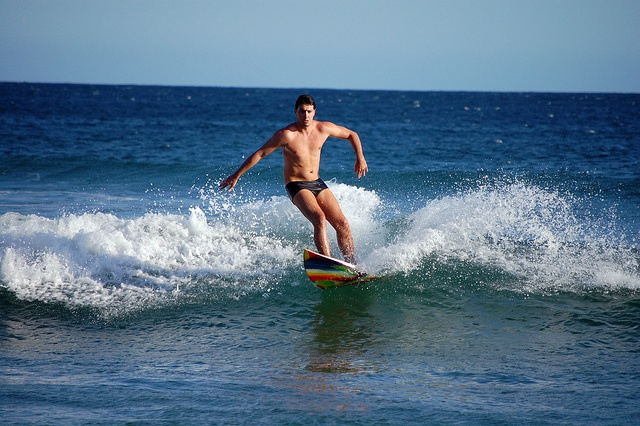Describe the objects in this image and their specific colors. I can see people in gray, black, maroon, tan, and salmon tones and surfboard in gray, black, maroon, and olive tones in this image. 